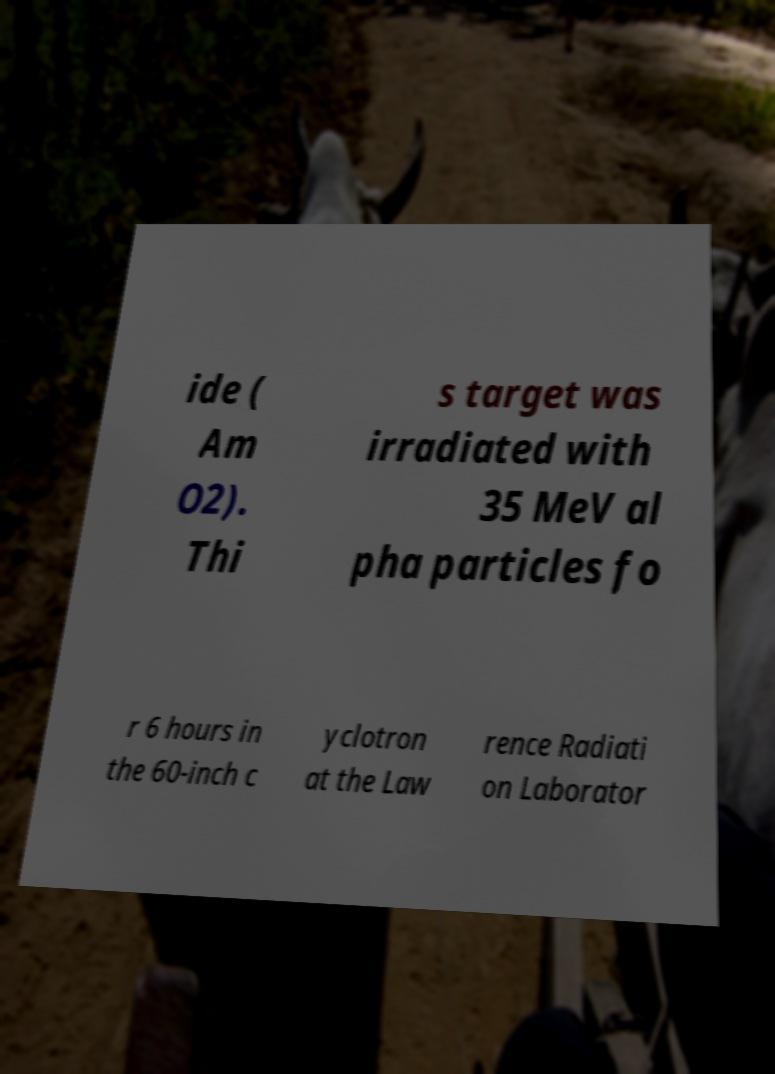Please read and relay the text visible in this image. What does it say? ide ( Am O2). Thi s target was irradiated with 35 MeV al pha particles fo r 6 hours in the 60-inch c yclotron at the Law rence Radiati on Laborator 